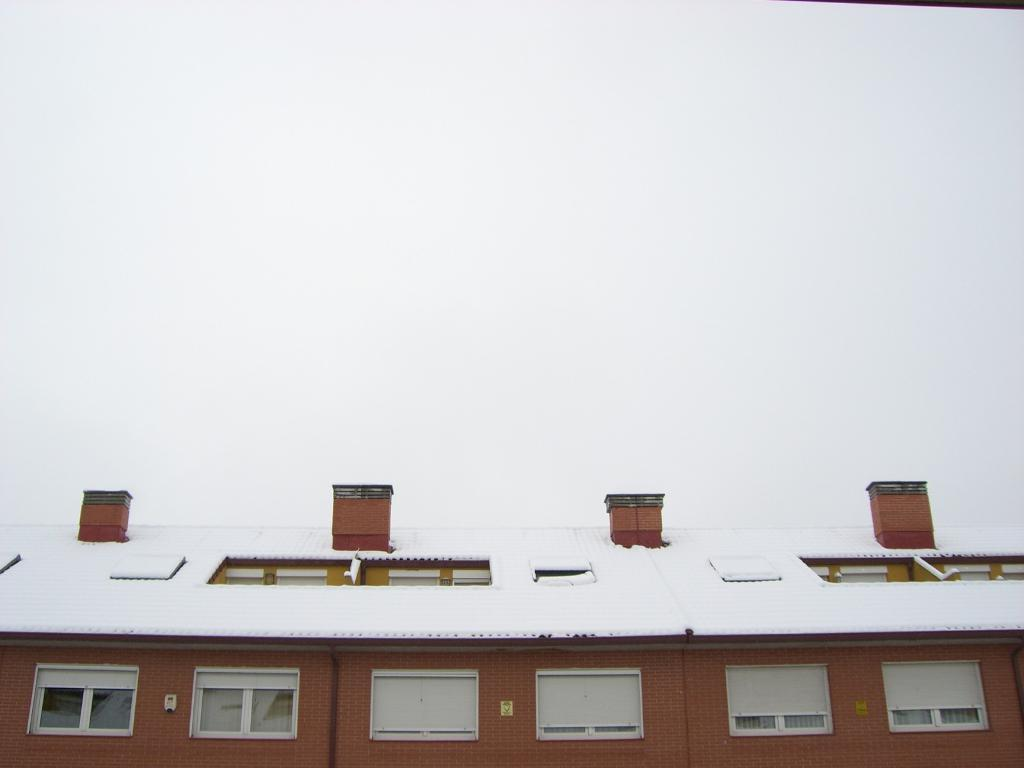What type of house is depicted in the image? There is a wooden house in the image. What is covering the roof of the house? The roof of the house is covered with snow. What can be seen in the background of the image? The sky is visible in the background of the image. How would you describe the sky in the image? The sky appears to be plain or clear. What type of hair can be seen on the roof of the house in the image? There is no hair present on the roof of the house in the image; it is covered with snow. 